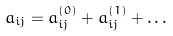Convert formula to latex. <formula><loc_0><loc_0><loc_500><loc_500>a _ { i j } = a ^ { ( 0 ) } _ { i j } + a ^ { ( 1 ) } _ { i j } + \dots</formula> 